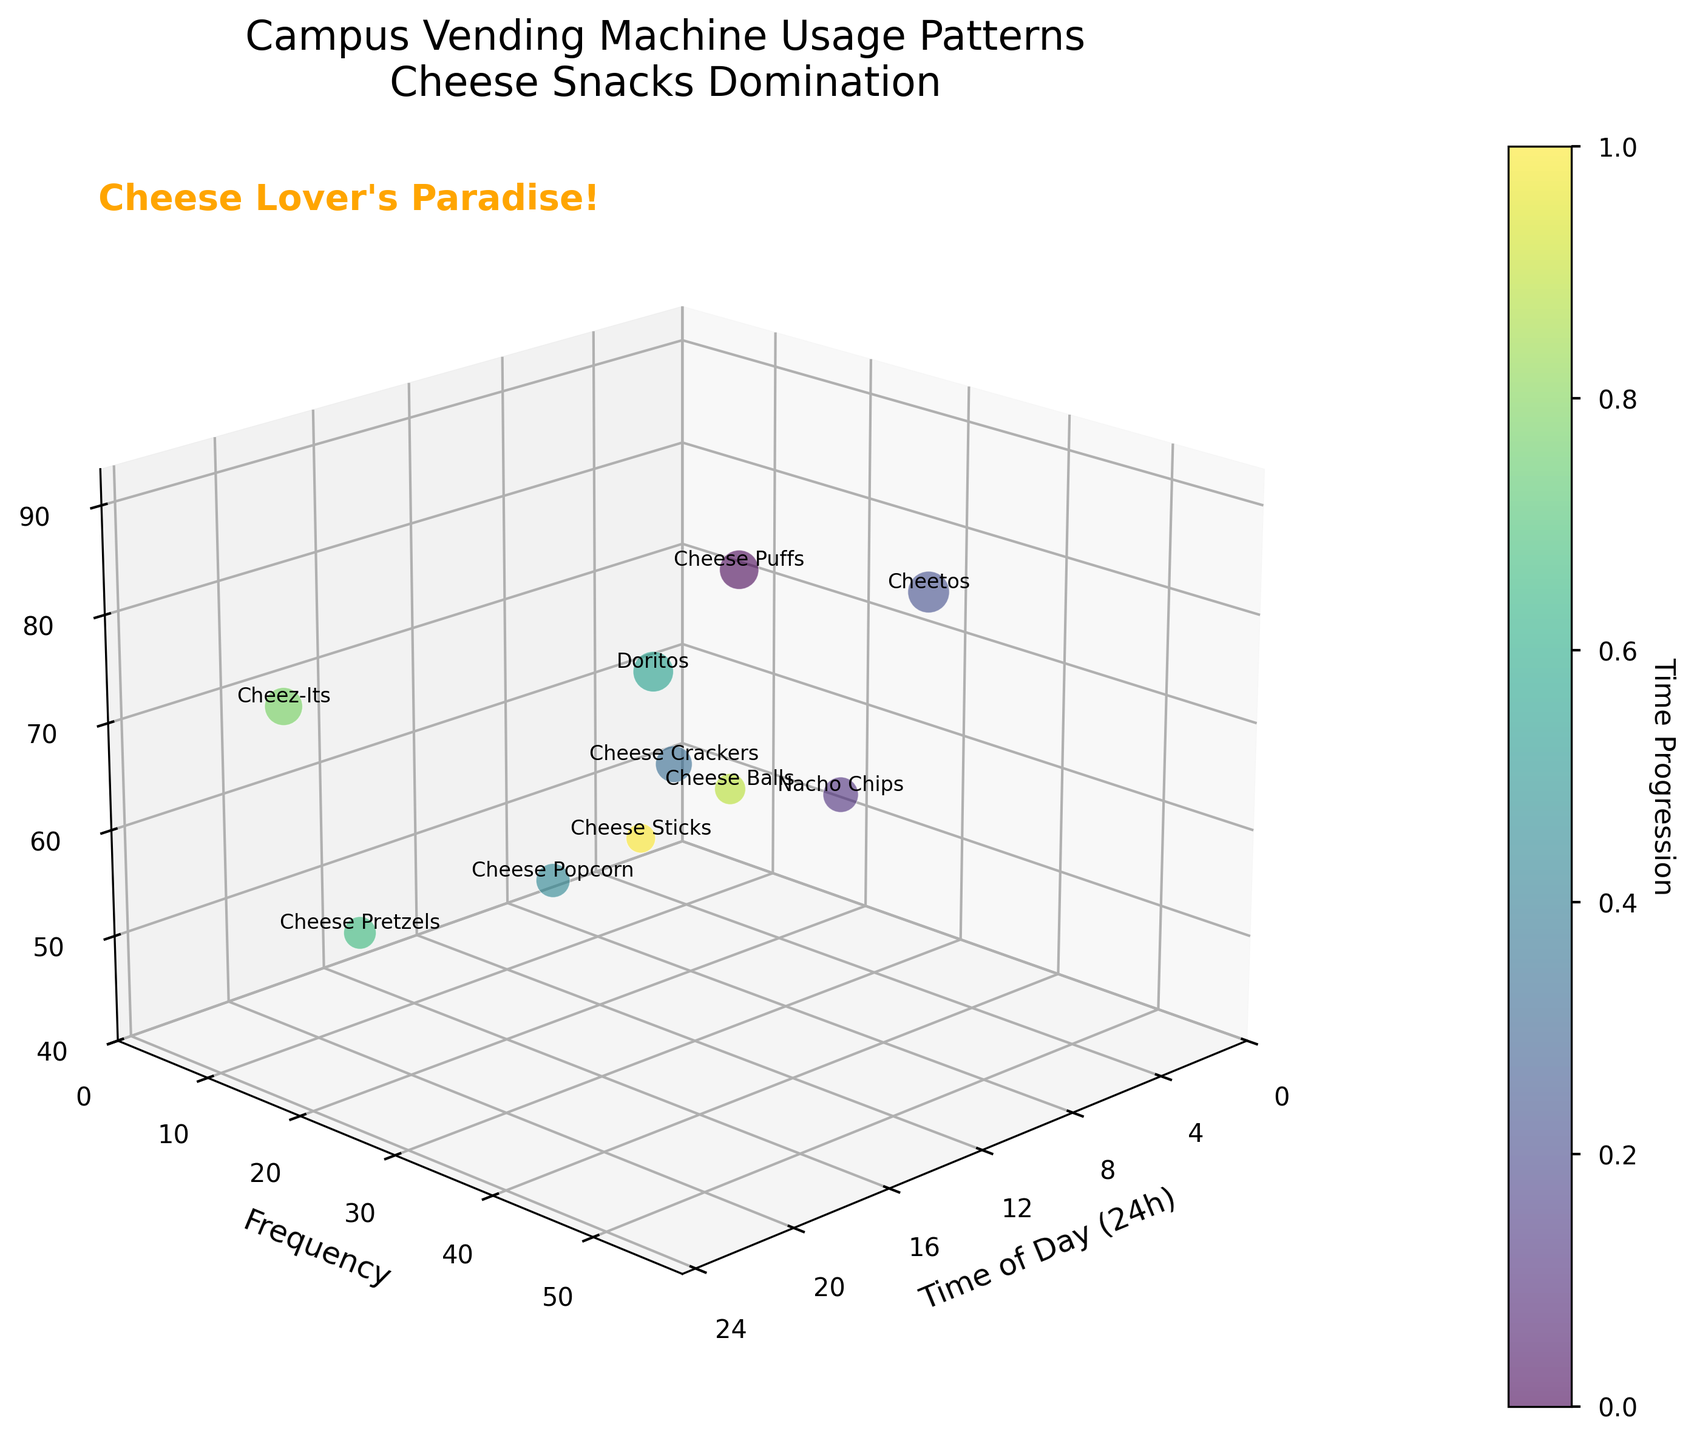What time of day has the highest frequency of vending machine usage? The data point with the highest frequency is around 13:00, with a frequency of 55.
Answer: 13:00 Which snack category has the highest popularity? The "Cheetos" category has the highest popularity with a value of 90, evident from the vertical axis ('Popularity').
Answer: Cheetos How many data points are represented in the figure? The figure has data points for 10 different time slots, each represented by a bubble.
Answer: 10 What does the title of the chart tell us about the data? The title "Campus Vending Machine Usage Patterns\nCheese Snacks Domination" indicates that the chart showcases the frequency, time of day, and popularity of snacks, with a focus on cheese-flavored snacks.
Answer: Campus Vending Machine Usage Patterns Which two snacks have the closest popularity values? "Nacho Chips" and "Cheese Crackers" have popularity values of 65 and 70, respectively, which are the closest compared to other pairs.
Answer: Nacho Chips and Cheese Crackers Between which two times is there the biggest drop in vending machine usage frequency? Between 20:30 and 2:00, the frequency drops from 45 to 10, making it a significant drop of 35 units.
Answer: 20:30 and 2:00 What time of day does the "Cheez-Its" category appear, and what is its popularity? "Cheez-Its" appears at 23:30, and its popularity is 75.
Answer: 23:30 and 75 Compare the popularity of "Cheese Puffs" and "Cheese Balls". Which one is more popular and by how much? "Cheese Puffs" has a popularity of 80, whereas "Cheese Balls" has a popularity of 50. Thus, "Cheese Puffs" is more popular by 30 units.
Answer: Cheese Puffs by 30 Which snack category appears earliest in the day, and what is its frequency? "Cheese Puffs" appears earliest at 8:00 with a frequency of 25.
Answer: Cheese Puffs and 25 What is the range of frequencies observed in the figure? The frequencies range from a minimum of 5 (for Cheese Sticks) to a maximum of 55 (for Cheetos), giving a range of 50.
Answer: 5 to 55 